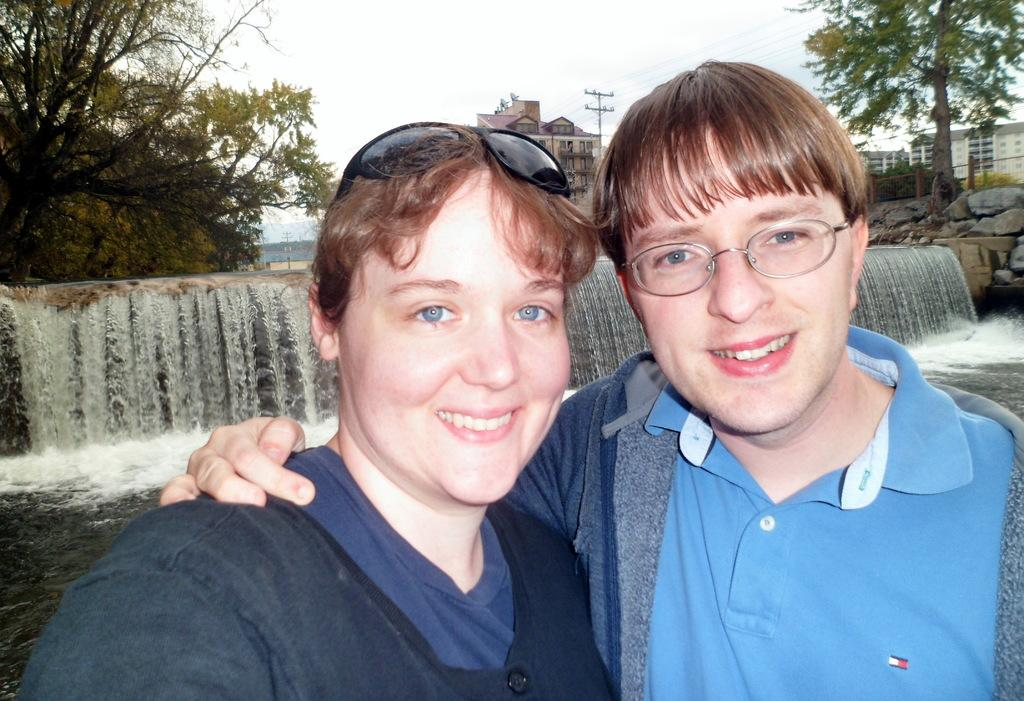Who is present in the image? There is a couple in the image. What are the couple doing in the image? The couple is standing in the front, smiling, and giving a pose to the camera. What can be seen in the background of the image? There is a small waterfall and trees in the background. Where is the dock located in the image? There is no dock present in the image. What type of basket is the fireman holding in the image? There is no fireman or basket present in the image. 